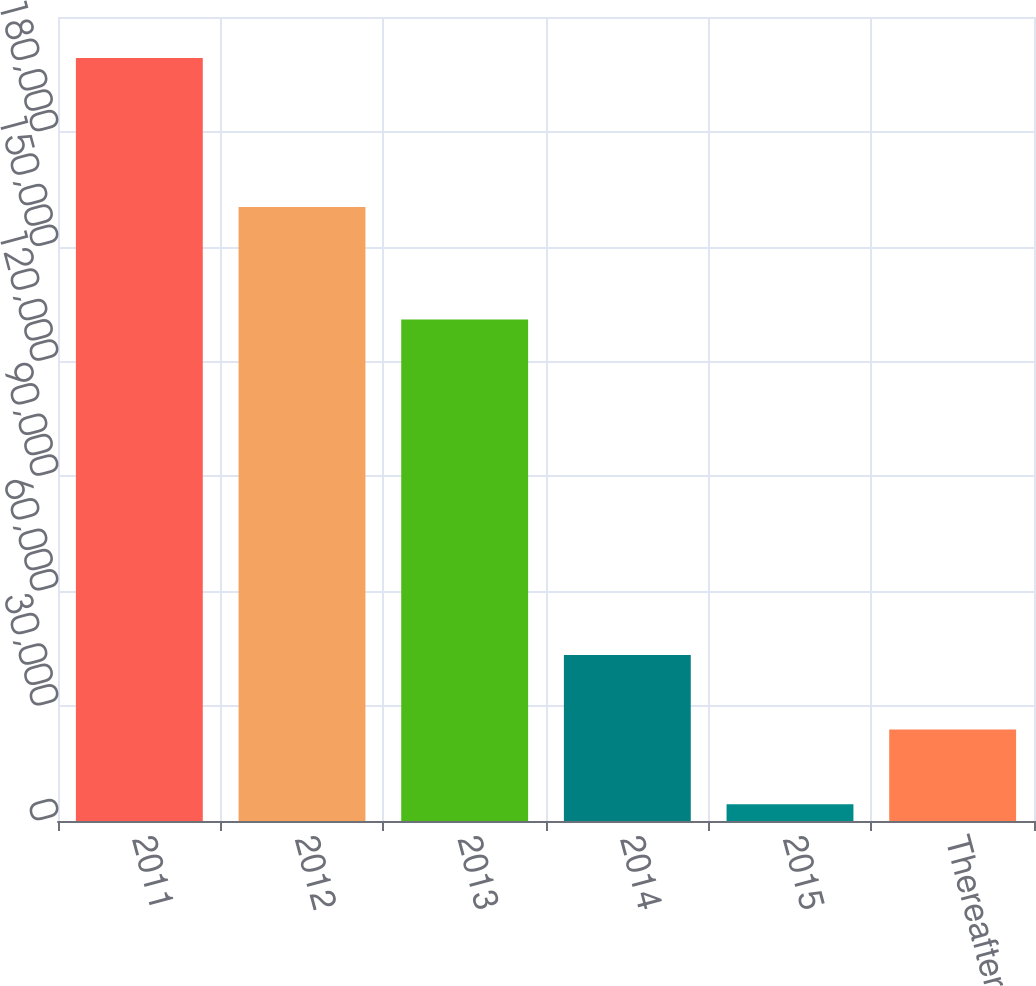<chart> <loc_0><loc_0><loc_500><loc_500><bar_chart><fcel>2011<fcel>2012<fcel>2013<fcel>2014<fcel>2015<fcel>Thereafter<nl><fcel>199259<fcel>160387<fcel>130990<fcel>43356.6<fcel>4381<fcel>23868.8<nl></chart> 